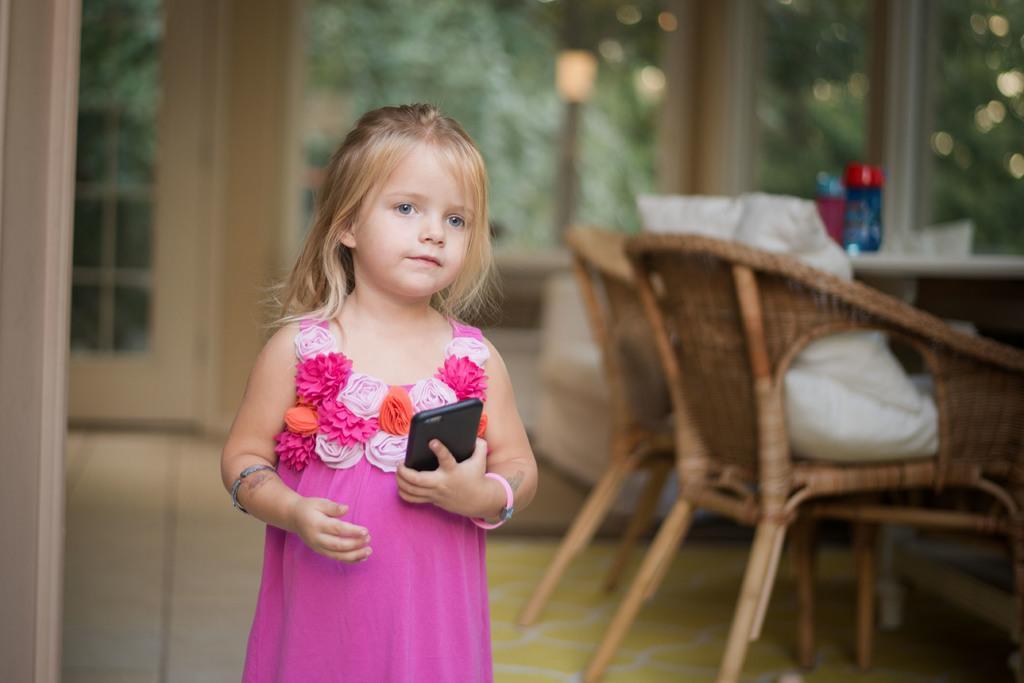How would you summarize this image in a sentence or two? In this image girl is standing on the floor and holding the mobile and beside the girl the chairs and tables are there behind the girl there is some big window and background is very sunny. 